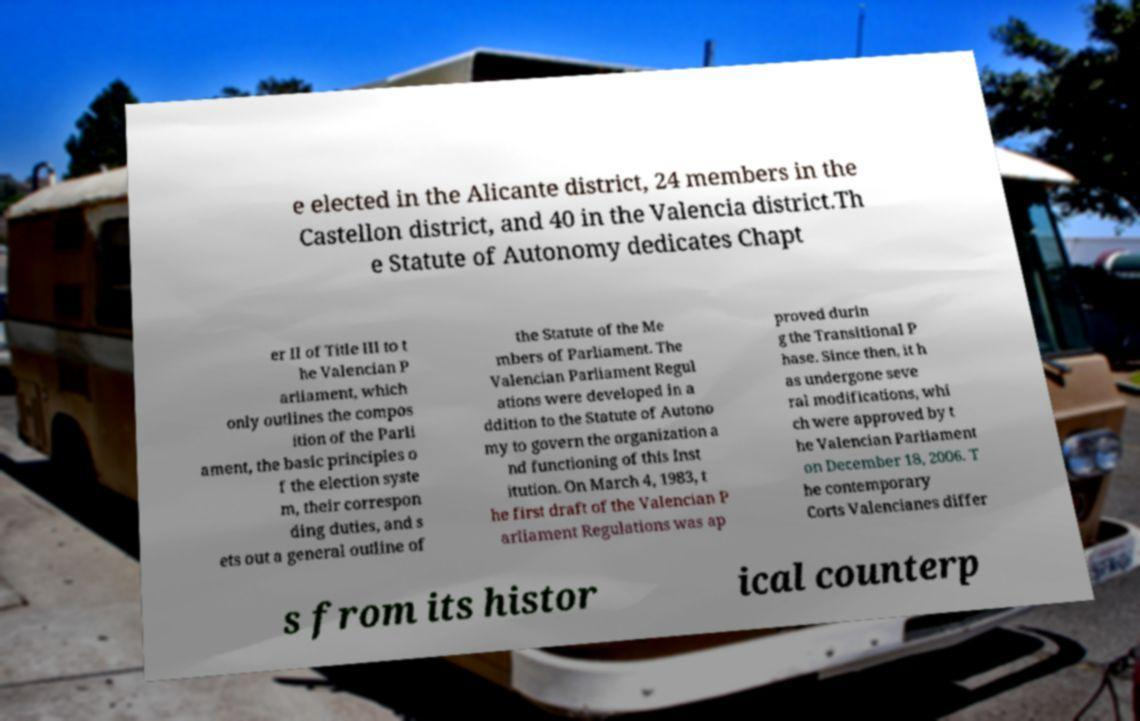For documentation purposes, I need the text within this image transcribed. Could you provide that? e elected in the Alicante district, 24 members in the Castellon district, and 40 in the Valencia district.Th e Statute of Autonomy dedicates Chapt er II of Title III to t he Valencian P arliament, which only outlines the compos ition of the Parli ament, the basic principles o f the election syste m, their correspon ding duties, and s ets out a general outline of the Statute of the Me mbers of Parliament. The Valencian Parliament Regul ations were developed in a ddition to the Statute of Autono my to govern the organization a nd functioning of this Inst itution. On March 4, 1983, t he first draft of the Valencian P arliament Regulations was ap proved durin g the Transitional P hase. Since then, it h as undergone seve ral modifications, whi ch were approved by t he Valencian Parliament on December 18, 2006. T he contemporary Corts Valencianes differ s from its histor ical counterp 